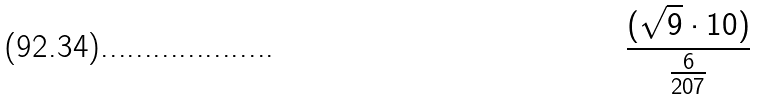<formula> <loc_0><loc_0><loc_500><loc_500>\frac { ( \sqrt { 9 } \cdot 1 0 ) } { \frac { 6 } { 2 0 7 } }</formula> 